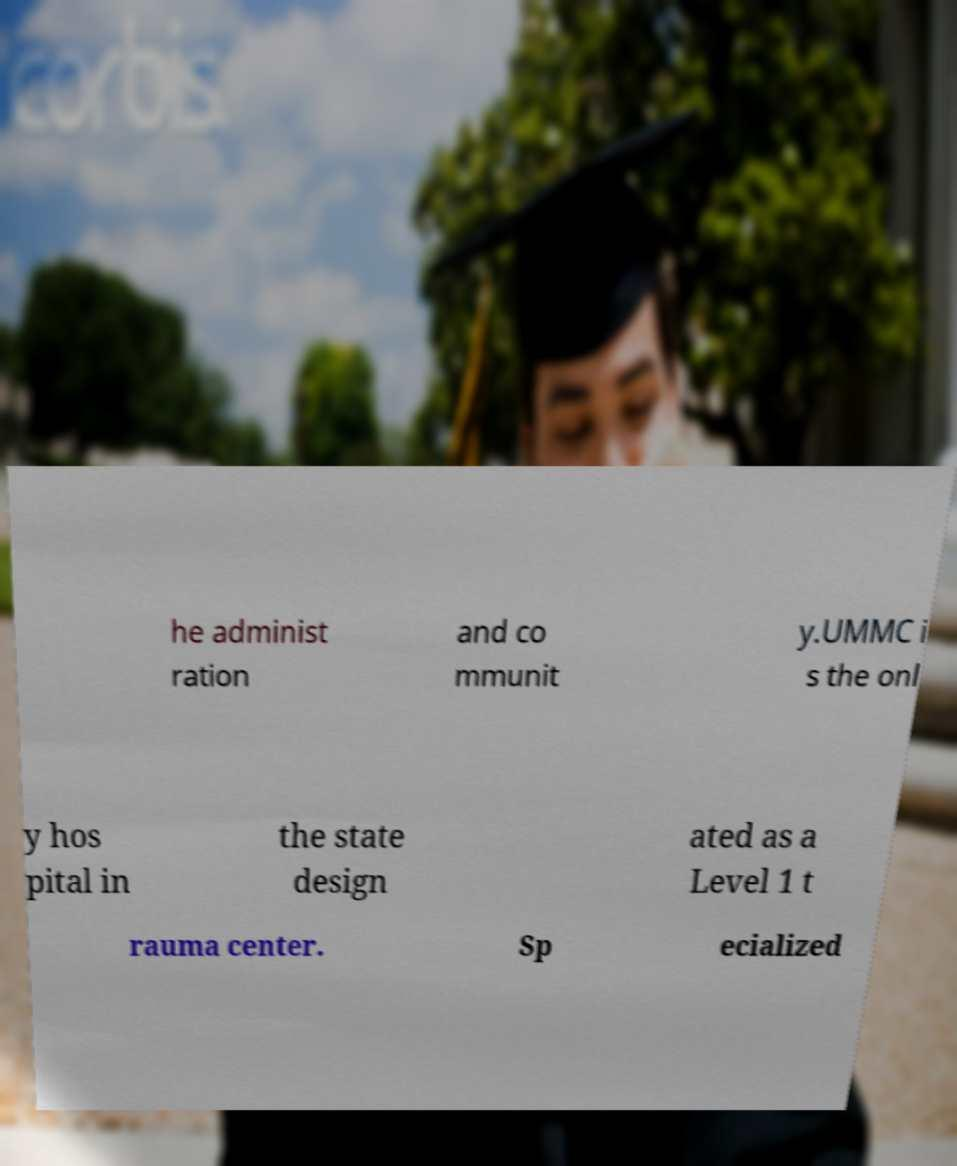Please identify and transcribe the text found in this image. he administ ration and co mmunit y.UMMC i s the onl y hos pital in the state design ated as a Level 1 t rauma center. Sp ecialized 